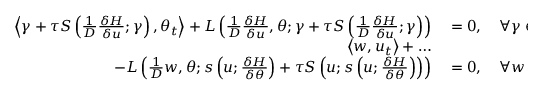<formula> <loc_0><loc_0><loc_500><loc_500>\begin{array} { r l } { \left \langle \gamma + \tau S \left ( \frac { 1 } { D } \frac { \delta H } { \delta u } ; \gamma \right ) , \theta _ { t } \right \rangle + L \left ( \frac { 1 } { D } \frac { \delta H } { \delta u } , \theta ; \gamma + \tau S \left ( \frac { 1 } { D } \frac { \delta H } { \delta u } ; \gamma \right ) \right ) } & = 0 , \quad \forall \gamma \in \mathbb { W } _ { \theta } , } \\ { \left \langle w , u _ { t } \right \rangle + \dots } \\ { \quad - L \left ( \frac { 1 } { D } w , \theta ; s \left ( u ; \frac { \delta H } { \delta \theta } \right ) + \tau S \left ( u ; s \left ( u ; \frac { \delta H } { \delta \theta } \right ) \right ) \right ) } & = 0 , \quad \forall w \in \mathbb { W } _ { h } ^ { 1 } , } \end{array}</formula> 